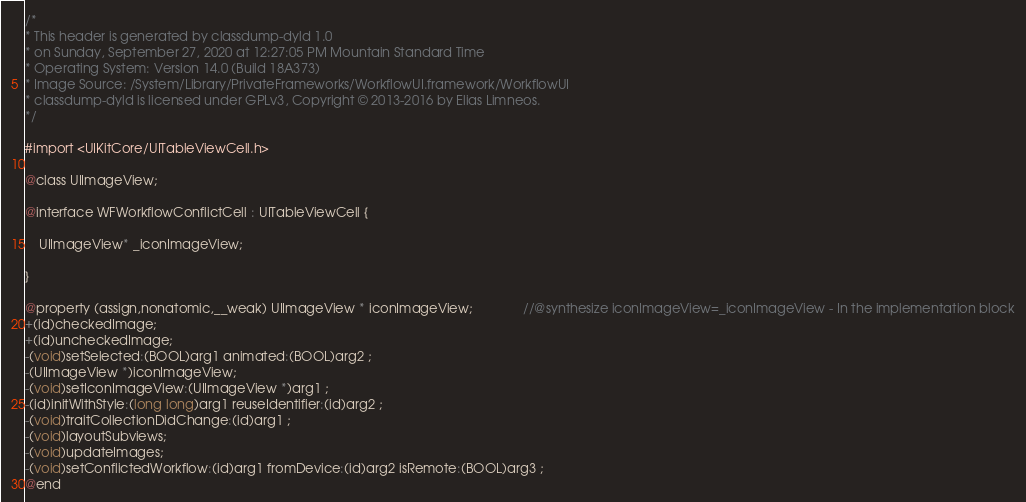<code> <loc_0><loc_0><loc_500><loc_500><_C_>/*
* This header is generated by classdump-dyld 1.0
* on Sunday, September 27, 2020 at 12:27:05 PM Mountain Standard Time
* Operating System: Version 14.0 (Build 18A373)
* Image Source: /System/Library/PrivateFrameworks/WorkflowUI.framework/WorkflowUI
* classdump-dyld is licensed under GPLv3, Copyright © 2013-2016 by Elias Limneos.
*/

#import <UIKitCore/UITableViewCell.h>

@class UIImageView;

@interface WFWorkflowConflictCell : UITableViewCell {

	UIImageView* _iconImageView;

}

@property (assign,nonatomic,__weak) UIImageView * iconImageView;              //@synthesize iconImageView=_iconImageView - In the implementation block
+(id)checkedImage;
+(id)uncheckedImage;
-(void)setSelected:(BOOL)arg1 animated:(BOOL)arg2 ;
-(UIImageView *)iconImageView;
-(void)setIconImageView:(UIImageView *)arg1 ;
-(id)initWithStyle:(long long)arg1 reuseIdentifier:(id)arg2 ;
-(void)traitCollectionDidChange:(id)arg1 ;
-(void)layoutSubviews;
-(void)updateImages;
-(void)setConflictedWorkflow:(id)arg1 fromDevice:(id)arg2 isRemote:(BOOL)arg3 ;
@end

</code> 